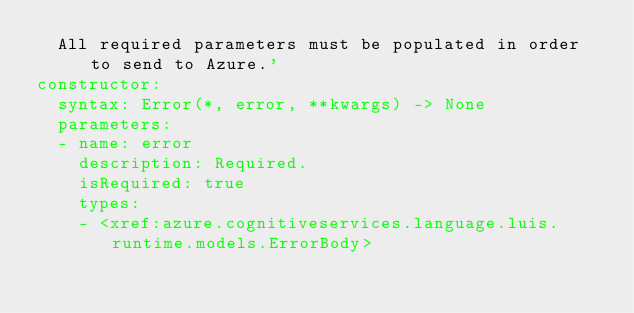Convert code to text. <code><loc_0><loc_0><loc_500><loc_500><_YAML_>  All required parameters must be populated in order to send to Azure.'
constructor:
  syntax: Error(*, error, **kwargs) -> None
  parameters:
  - name: error
    description: Required.
    isRequired: true
    types:
    - <xref:azure.cognitiveservices.language.luis.runtime.models.ErrorBody>
</code> 